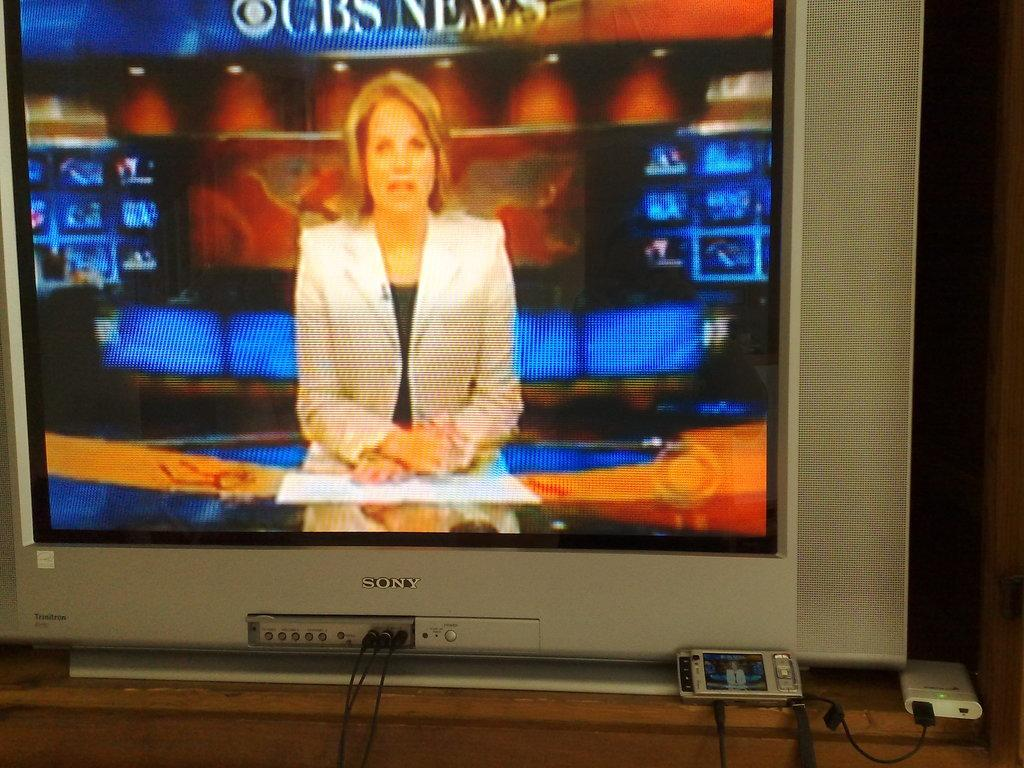<image>
Give a short and clear explanation of the subsequent image. Sony Television Screen that has on CBS News with I think Katie Couric. 